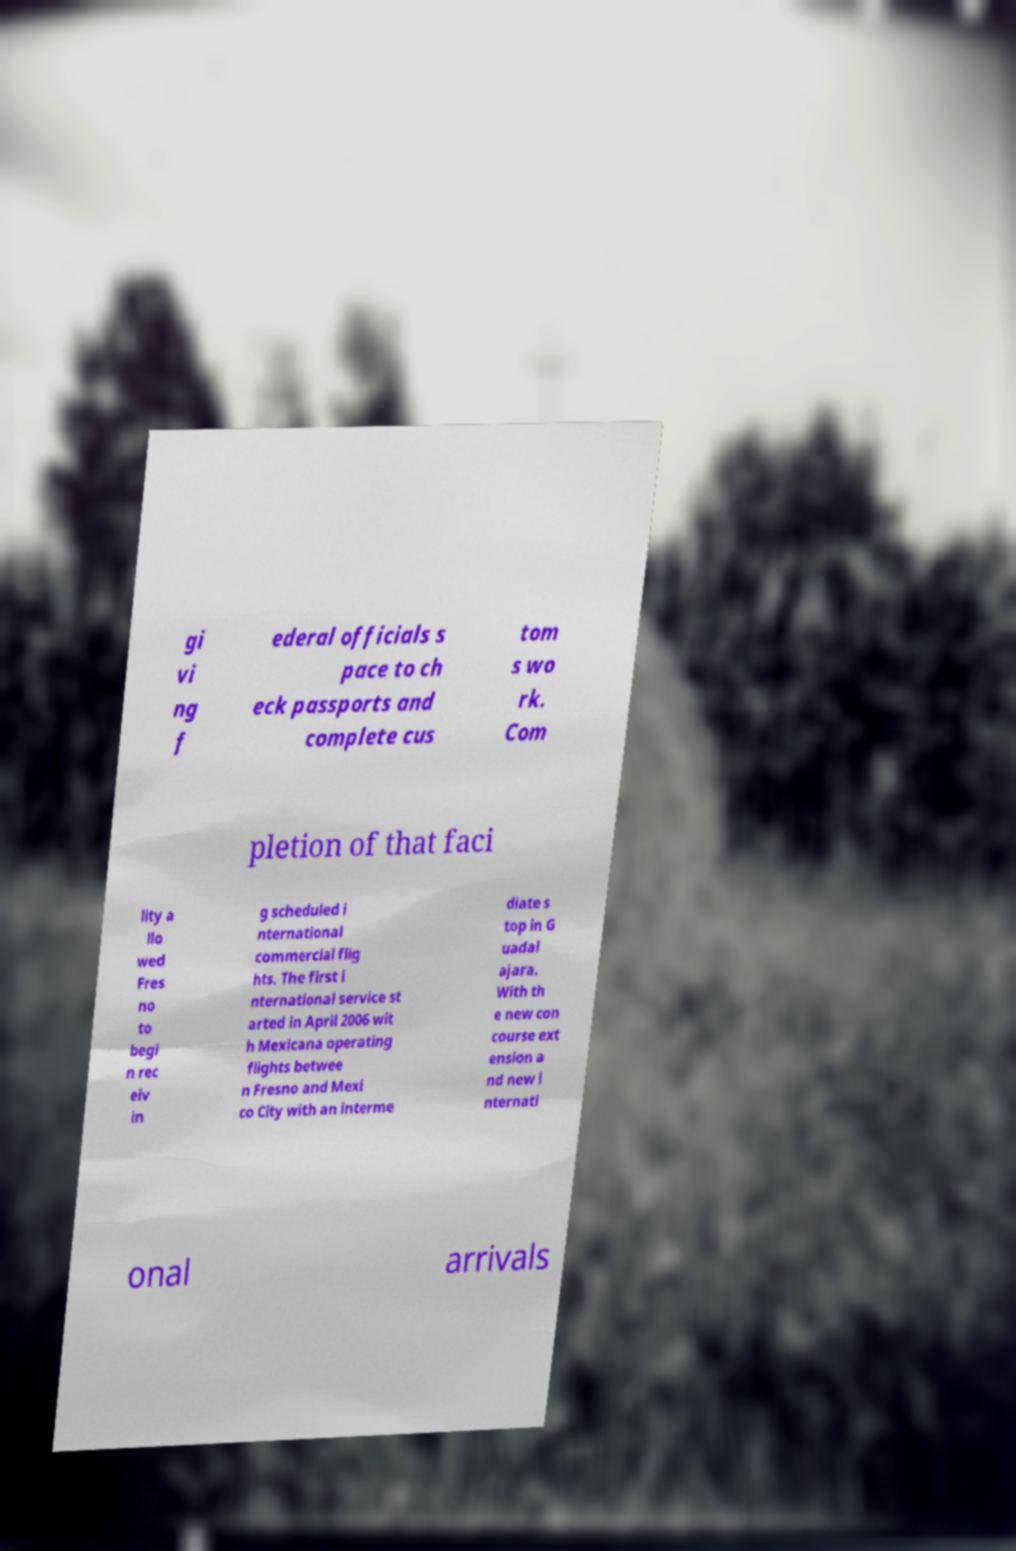What messages or text are displayed in this image? I need them in a readable, typed format. gi vi ng f ederal officials s pace to ch eck passports and complete cus tom s wo rk. Com pletion of that faci lity a llo wed Fres no to begi n rec eiv in g scheduled i nternational commercial flig hts. The first i nternational service st arted in April 2006 wit h Mexicana operating flights betwee n Fresno and Mexi co City with an interme diate s top in G uadal ajara. With th e new con course ext ension a nd new i nternati onal arrivals 